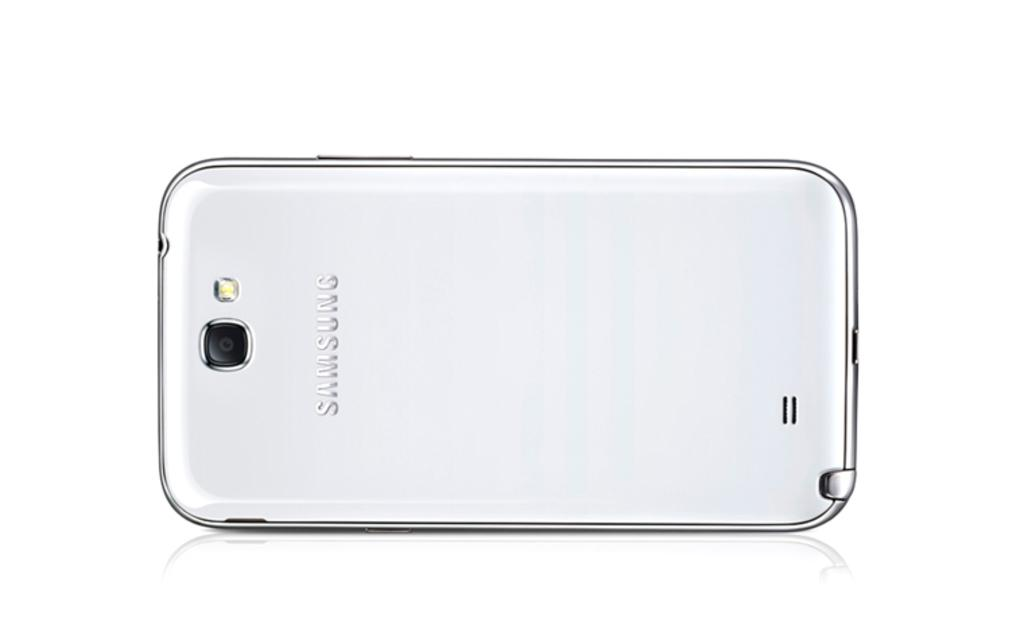<image>
Provide a brief description of the given image. A white Samsung phone sitting face down on a white surface. 